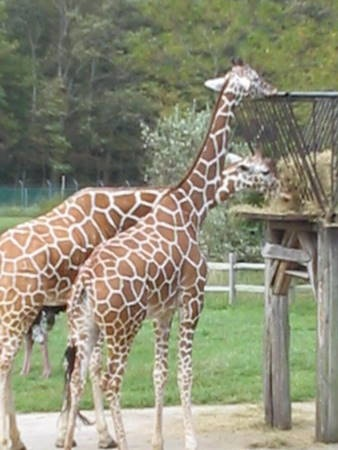Describe the objects in this image and their specific colors. I can see giraffe in gray, darkgray, and lightgray tones and giraffe in gray, lightgray, and tan tones in this image. 